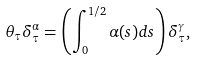<formula> <loc_0><loc_0><loc_500><loc_500>\theta _ { \tau } \delta _ { \tau } ^ { \alpha } = \left ( \int _ { 0 } ^ { 1 / 2 } \alpha ( s ) d s \right ) \delta _ { \tau } ^ { \gamma } ,</formula> 